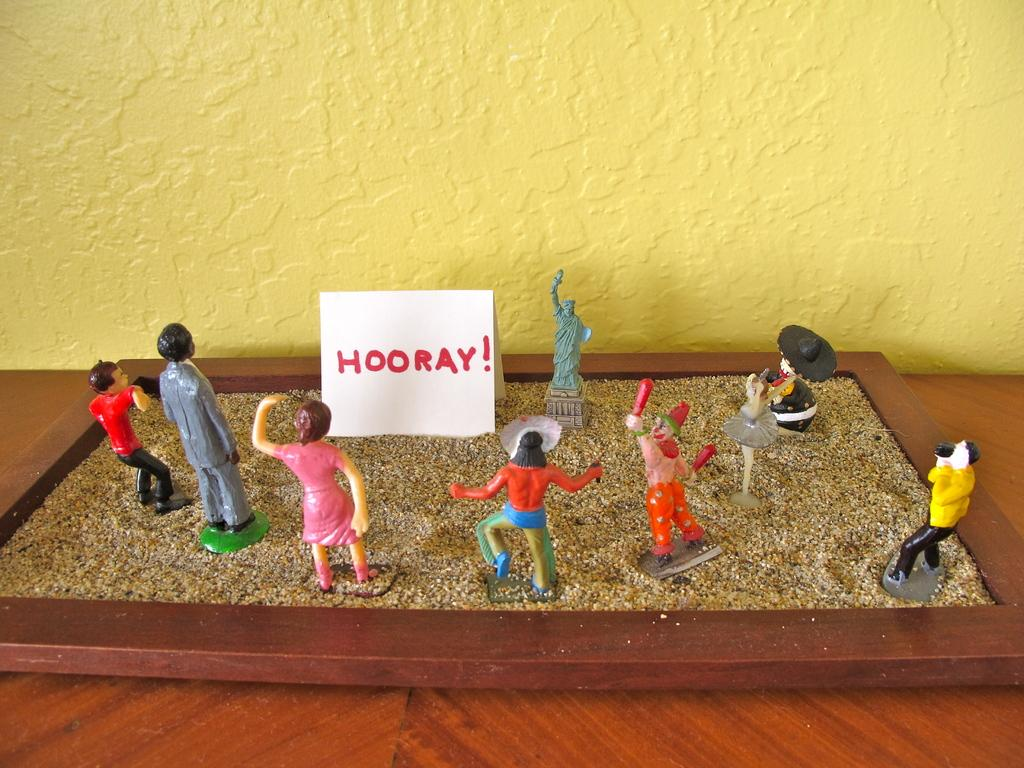What is in the tray that is visible in the image? There are toys in a tray of sand in the image. Where is the tray of sand located? The tray of sand is on a table in the image. What color is the wall visible in the image? The wall in the image is yellow. How many snakes can be seen slithering on the yellow wall in the image? There are no snakes visible in the image; it features toys in a tray of sand on a table with a yellow wall. 